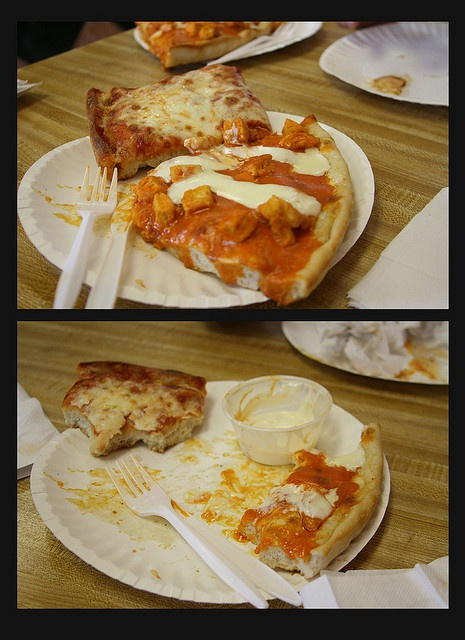Describe the objects in this image and their specific colors. I can see dining table in black, olive, darkgray, and tan tones, dining table in black, olive, and maroon tones, pizza in black, brown, khaki, maroon, and tan tones, pizza in black, brown, tan, and maroon tones, and pizza in black, olive, tan, and maroon tones in this image. 